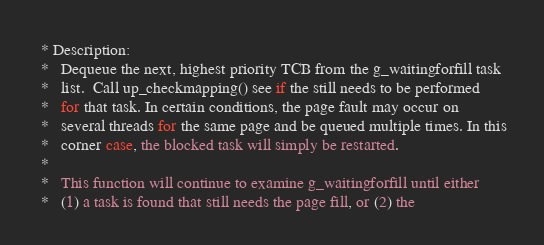Convert code to text. <code><loc_0><loc_0><loc_500><loc_500><_C_> * Description:
 *   Dequeue the next, highest priority TCB from the g_waitingforfill task
 *   list.  Call up_checkmapping() see if the still needs to be performed
 *   for that task. In certain conditions, the page fault may occur on
 *   several threads for the same page and be queued multiple times. In this
 *   corner case, the blocked task will simply be restarted.
 *
 *   This function will continue to examine g_waitingforfill until either
 *   (1) a task is found that still needs the page fill, or (2) the</code> 